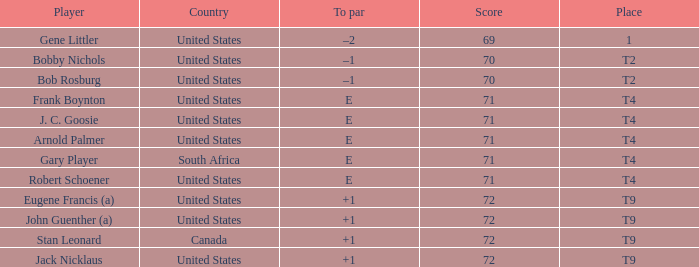What is To Par, when Country is "United States", when Place is "T4", and when Player is "Arnold Palmer"? E. Give me the full table as a dictionary. {'header': ['Player', 'Country', 'To par', 'Score', 'Place'], 'rows': [['Gene Littler', 'United States', '–2', '69', '1'], ['Bobby Nichols', 'United States', '–1', '70', 'T2'], ['Bob Rosburg', 'United States', '–1', '70', 'T2'], ['Frank Boynton', 'United States', 'E', '71', 'T4'], ['J. C. Goosie', 'United States', 'E', '71', 'T4'], ['Arnold Palmer', 'United States', 'E', '71', 'T4'], ['Gary Player', 'South Africa', 'E', '71', 'T4'], ['Robert Schoener', 'United States', 'E', '71', 'T4'], ['Eugene Francis (a)', 'United States', '+1', '72', 'T9'], ['John Guenther (a)', 'United States', '+1', '72', 'T9'], ['Stan Leonard', 'Canada', '+1', '72', 'T9'], ['Jack Nicklaus', 'United States', '+1', '72', 'T9']]} 